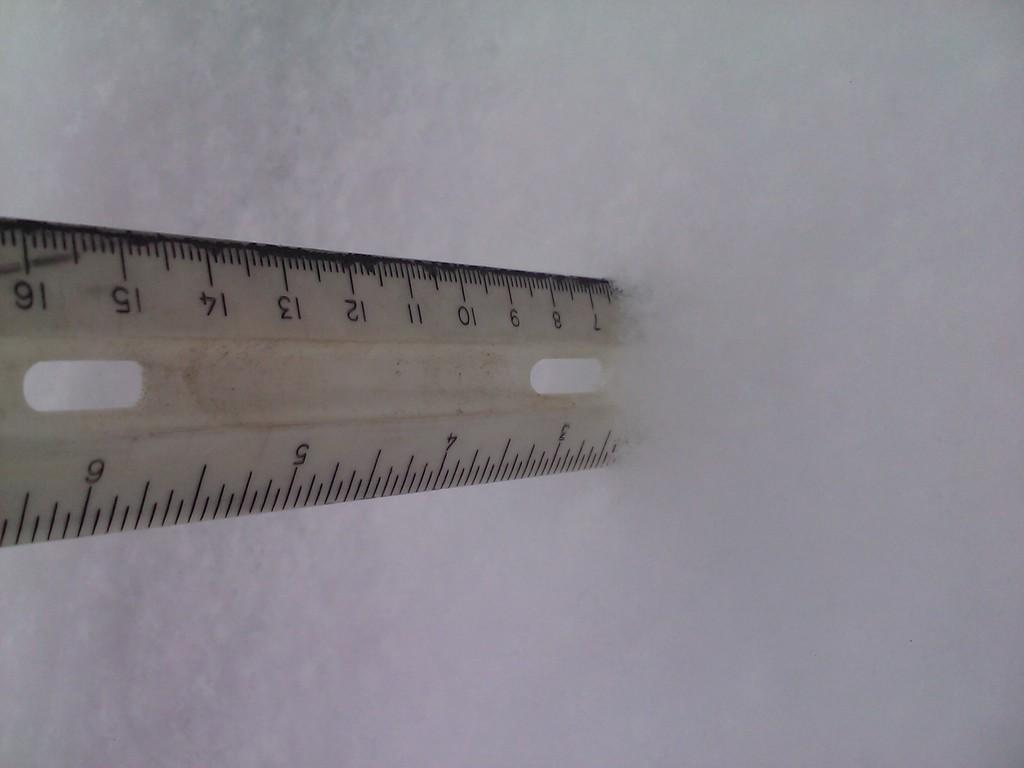<image>
Provide a brief description of the given image. A rules is sticking out of the snow, showing the depth at about 2 and a half inches. 